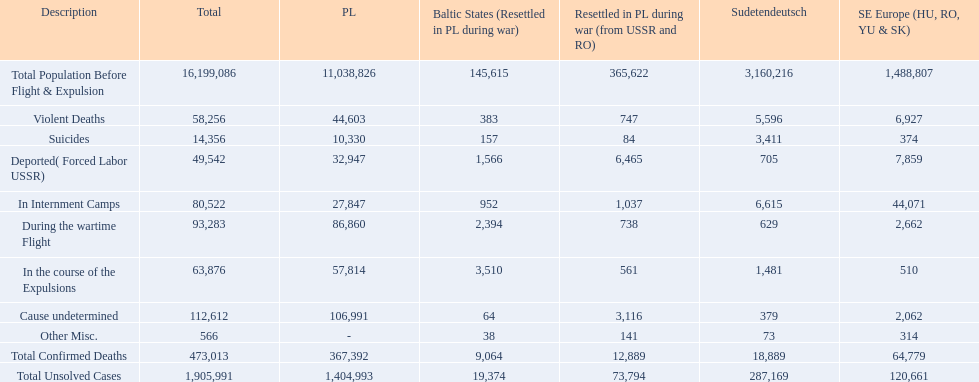What was the cause of the most deaths? Cause undetermined. 